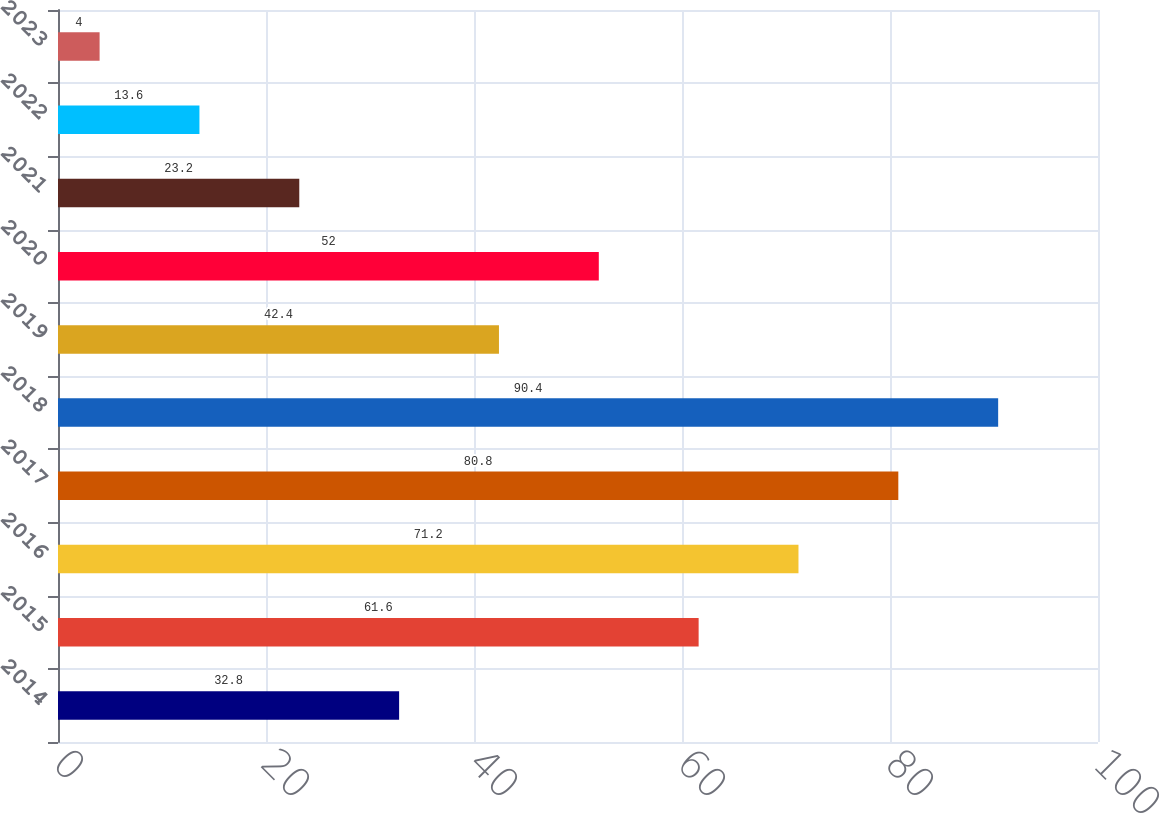Convert chart. <chart><loc_0><loc_0><loc_500><loc_500><bar_chart><fcel>2014<fcel>2015<fcel>2016<fcel>2017<fcel>2018<fcel>2019<fcel>2020<fcel>2021<fcel>2022<fcel>2023<nl><fcel>32.8<fcel>61.6<fcel>71.2<fcel>80.8<fcel>90.4<fcel>42.4<fcel>52<fcel>23.2<fcel>13.6<fcel>4<nl></chart> 